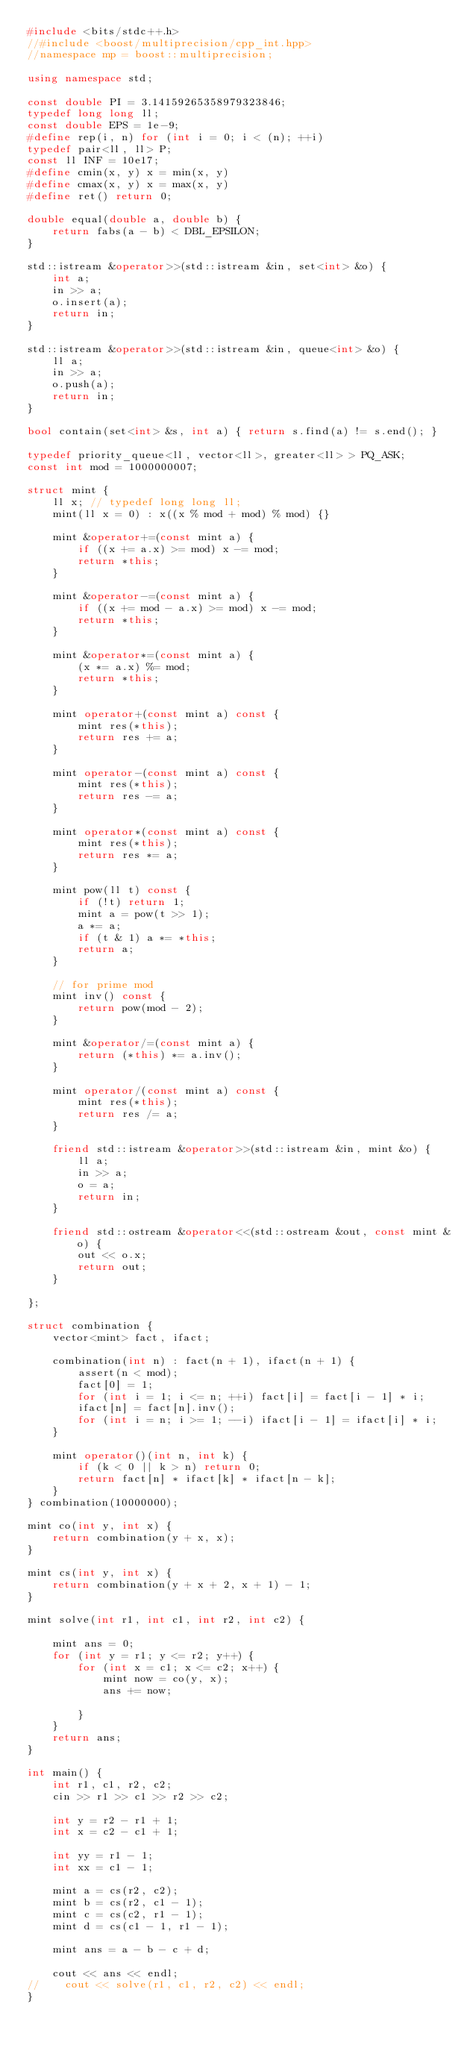<code> <loc_0><loc_0><loc_500><loc_500><_C++_>#include <bits/stdc++.h>
//#include <boost/multiprecision/cpp_int.hpp>
//namespace mp = boost::multiprecision;

using namespace std;

const double PI = 3.14159265358979323846;
typedef long long ll;
const double EPS = 1e-9;
#define rep(i, n) for (int i = 0; i < (n); ++i)
typedef pair<ll, ll> P;
const ll INF = 10e17;
#define cmin(x, y) x = min(x, y)
#define cmax(x, y) x = max(x, y)
#define ret() return 0;

double equal(double a, double b) {
    return fabs(a - b) < DBL_EPSILON;
}

std::istream &operator>>(std::istream &in, set<int> &o) {
    int a;
    in >> a;
    o.insert(a);
    return in;
}

std::istream &operator>>(std::istream &in, queue<int> &o) {
    ll a;
    in >> a;
    o.push(a);
    return in;
}

bool contain(set<int> &s, int a) { return s.find(a) != s.end(); }

typedef priority_queue<ll, vector<ll>, greater<ll> > PQ_ASK;
const int mod = 1000000007;

struct mint {
    ll x; // typedef long long ll;
    mint(ll x = 0) : x((x % mod + mod) % mod) {}

    mint &operator+=(const mint a) {
        if ((x += a.x) >= mod) x -= mod;
        return *this;
    }

    mint &operator-=(const mint a) {
        if ((x += mod - a.x) >= mod) x -= mod;
        return *this;
    }

    mint &operator*=(const mint a) {
        (x *= a.x) %= mod;
        return *this;
    }

    mint operator+(const mint a) const {
        mint res(*this);
        return res += a;
    }

    mint operator-(const mint a) const {
        mint res(*this);
        return res -= a;
    }

    mint operator*(const mint a) const {
        mint res(*this);
        return res *= a;
    }

    mint pow(ll t) const {
        if (!t) return 1;
        mint a = pow(t >> 1);
        a *= a;
        if (t & 1) a *= *this;
        return a;
    }

    // for prime mod
    mint inv() const {
        return pow(mod - 2);
    }

    mint &operator/=(const mint a) {
        return (*this) *= a.inv();
    }

    mint operator/(const mint a) const {
        mint res(*this);
        return res /= a;
    }

    friend std::istream &operator>>(std::istream &in, mint &o) {
        ll a;
        in >> a;
        o = a;
        return in;
    }

    friend std::ostream &operator<<(std::ostream &out, const mint &o) {
        out << o.x;
        return out;
    }

};

struct combination {
    vector<mint> fact, ifact;

    combination(int n) : fact(n + 1), ifact(n + 1) {
        assert(n < mod);
        fact[0] = 1;
        for (int i = 1; i <= n; ++i) fact[i] = fact[i - 1] * i;
        ifact[n] = fact[n].inv();
        for (int i = n; i >= 1; --i) ifact[i - 1] = ifact[i] * i;
    }

    mint operator()(int n, int k) {
        if (k < 0 || k > n) return 0;
        return fact[n] * ifact[k] * ifact[n - k];
    }
} combination(10000000);

mint co(int y, int x) {
    return combination(y + x, x);
}

mint cs(int y, int x) {
    return combination(y + x + 2, x + 1) - 1;
}

mint solve(int r1, int c1, int r2, int c2) {

    mint ans = 0;
    for (int y = r1; y <= r2; y++) {
        for (int x = c1; x <= c2; x++) {
            mint now = co(y, x);
            ans += now;

        }
    }
    return ans;
}

int main() {
    int r1, c1, r2, c2;
    cin >> r1 >> c1 >> r2 >> c2;

    int y = r2 - r1 + 1;
    int x = c2 - c1 + 1;

    int yy = r1 - 1;
    int xx = c1 - 1;

    mint a = cs(r2, c2);
    mint b = cs(r2, c1 - 1);
    mint c = cs(c2, r1 - 1);
    mint d = cs(c1 - 1, r1 - 1);

    mint ans = a - b - c + d;

    cout << ans << endl;
//    cout << solve(r1, c1, r2, c2) << endl;
}</code> 